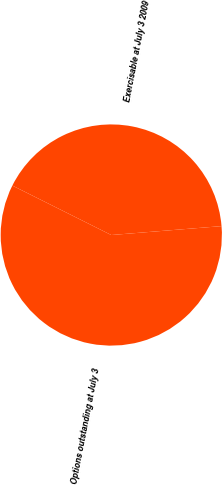<chart> <loc_0><loc_0><loc_500><loc_500><pie_chart><fcel>Options outstanding at July 3<fcel>Exercisable at July 3 2009<nl><fcel>58.66%<fcel>41.34%<nl></chart> 